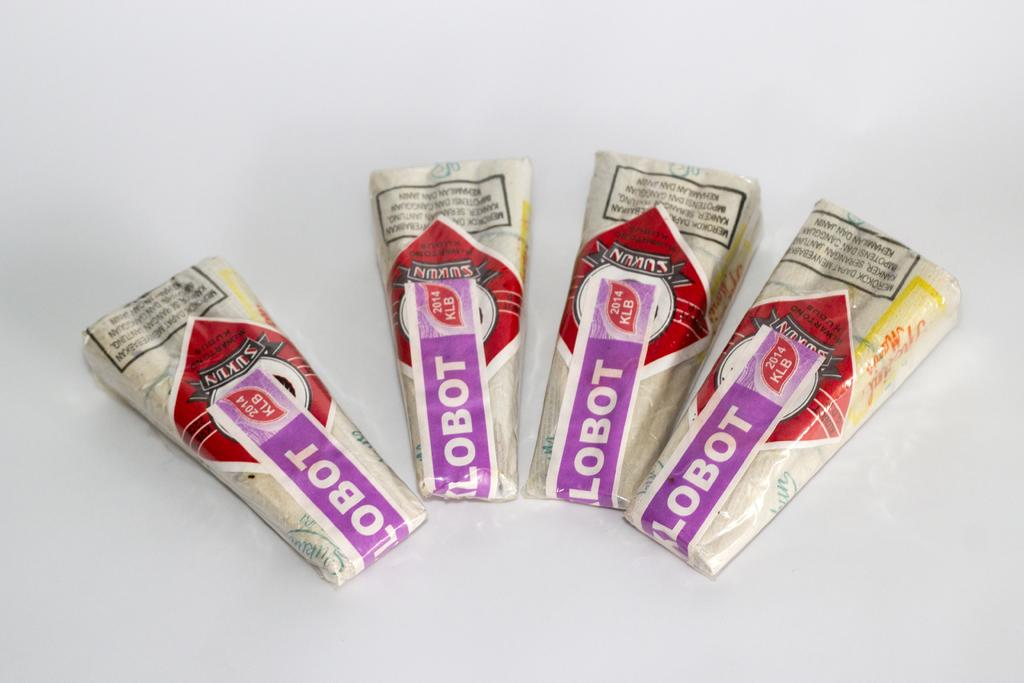What objects are present in the image? There are four sealed cigarette packets in the image. Where are the cigarette packets placed? The cigarette packets are kept on a surface. Can you see any trails left by the cigarette packets in the image? There are no trails visible in the image, as the cigarette packets are stationary on the surface. What type of friction might be present between the cigarette packets and the surface they are placed on? The image does not provide enough information to determine the type of friction between the cigarette packets and the surface. Are there any visible teeth on the cigarette packets in the image? There are no teeth present on the cigarette packets in the image, as they are sealed and not animate objects. 